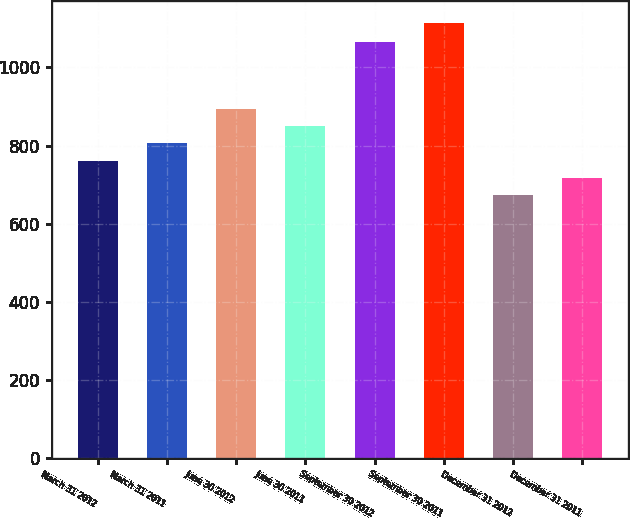Convert chart. <chart><loc_0><loc_0><loc_500><loc_500><bar_chart><fcel>March 31 2012<fcel>March 31 2011<fcel>June 30 2012<fcel>June 30 2011<fcel>September 30 2012<fcel>September 30 2011<fcel>December 31 2012<fcel>December 31 2011<nl><fcel>761.4<fcel>805.6<fcel>894<fcel>849.8<fcel>1064<fcel>1115<fcel>673<fcel>717.2<nl></chart> 